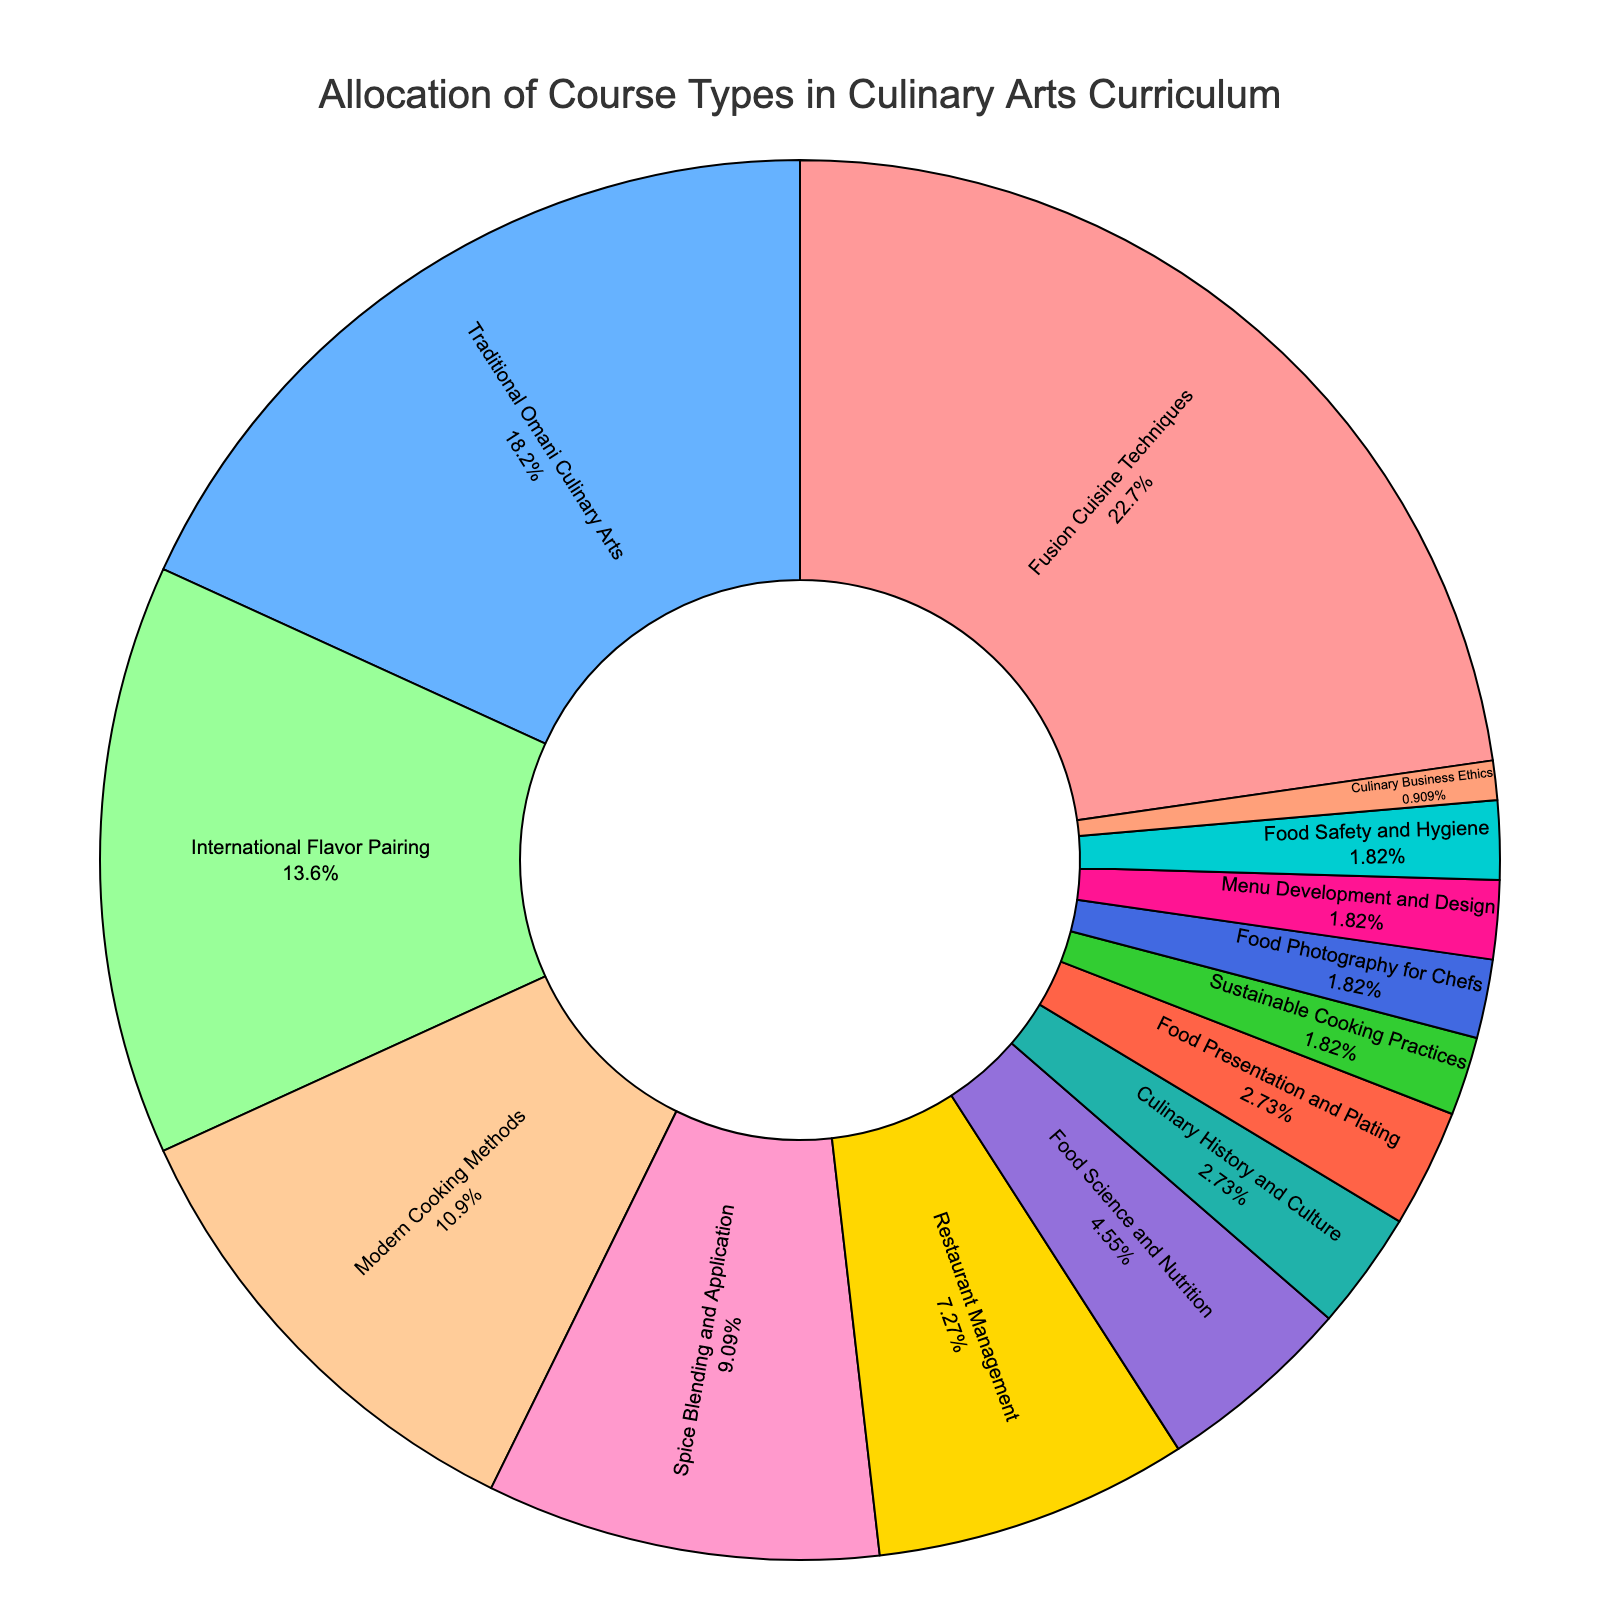What percentage of the curriculum is allocated to courses focusing on culinary history and culture? Look at the slice labeled "Culinary History and Culture" in the pie chart. It shows a percentage of 3%.
Answer: 3% How does the allocation for Fusion Cuisine Techniques compare to Modern Cooking Methods? Find the slices labeled "Fusion Cuisine Techniques" and "Modern Cooking Methods" in the pie chart. The percentages for these are 25% and 12%, respectively. Fusion Cuisine Techniques has a larger allocation.
Answer: Fusion Cuisine Techniques has a larger allocation What is the combined percentage of courses related to restaurant management and culinary business ethics? Locate the slices for "Restaurant Management" and "Culinary Business Ethics", which have percentages of 8% and 1%, respectively. Add these two percentages: 8% + 1% = 9%.
Answer: 9% What categories make up at least 20% of the curriculum? Identify the categories that have a percentage of at least 20%. In this case, "Fusion Cuisine Techniques" (25%) and "Traditional Omani Culinary Arts" (20%) meet this criterion.
Answer: Fusion Cuisine Techniques, Traditional Omani Culinary Arts By how much does the allocation for International Flavor Pairing exceed Spice Blending and Application? Find the percentages for "International Flavor Pairing" and "Spice Blending and Application," which are 15% and 10%, respectively. Subtract the smaller percentage from the larger one: 15% - 10% = 5%.
Answer: 5% Which two categories have the smallest allocation percentages, and what are they? Find the slices with the lowest percentages. "Culinary Business Ethics," "Food Photography for Chefs," "Menu Development and Design," "Food Safety and Hygiene," and "Sustainable Cooking Practices" all have 2%. The required two categories can be any two of these.
Answer: Culinary Business Ethics, Sustainable Cooking Practices (or any other pair from the lowest percentages) What is the difference in the allocation between the largest and smallest slices? Determine the largest and smallest slices. "Fusion Cuisine Techniques" is the largest at 25%, and "Culinary Business Ethics" is the smallest at 1%. Subtract the smallest from the largest: 25% - 1% = 24%.
Answer: 24% What is the average percentage allocation for Food Science and Nutrition, Culinary History and Culture, and Food Safety and Hygiene? Find the percentages: Food Science and Nutrition (5%), Culinary History and Culture (3%), and Food Safety and Hygiene (2%). Calculate the average: (5% + 3% + 2%) / 3 = 3.33%.
Answer: 3.33% How many categories make up less than 5% of the curriculum each? Identify all slices with less than 5%. These categories are Food Science and Nutrition (5%), Culinary History and Culture (3%), Food Presentation and Plating (3%), Sustainable Cooking Practices (2%), Food Photography for Chefs (2%), Menu Development and Design (2%), Food Safety and Hygiene (2%), and Culinary Business Ethics (1%). There are 8 such categories.
Answer: 8 